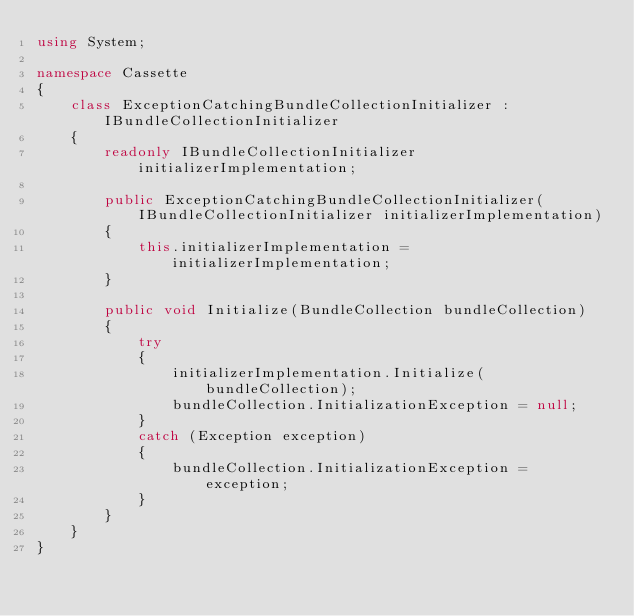Convert code to text. <code><loc_0><loc_0><loc_500><loc_500><_C#_>using System;

namespace Cassette
{
    class ExceptionCatchingBundleCollectionInitializer : IBundleCollectionInitializer
    {
        readonly IBundleCollectionInitializer initializerImplementation;

        public ExceptionCatchingBundleCollectionInitializer(IBundleCollectionInitializer initializerImplementation)
        {
            this.initializerImplementation = initializerImplementation;
        }

        public void Initialize(BundleCollection bundleCollection)
        {
            try
            {
                initializerImplementation.Initialize(bundleCollection);
                bundleCollection.InitializationException = null;
            }
            catch (Exception exception)
            {
                bundleCollection.InitializationException = exception;
            }
        }
    }
}</code> 